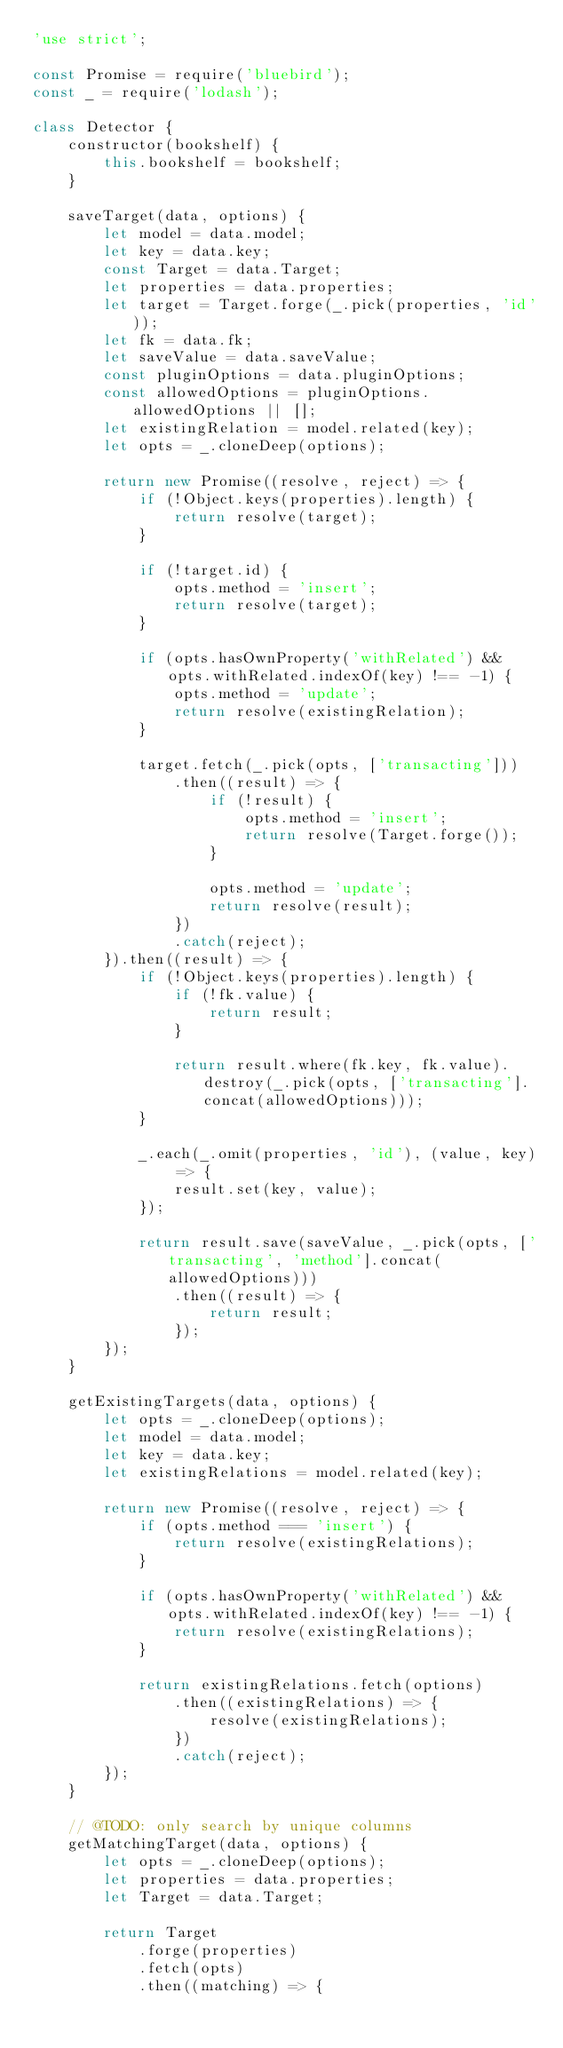Convert code to text. <code><loc_0><loc_0><loc_500><loc_500><_JavaScript_>'use strict';

const Promise = require('bluebird');
const _ = require('lodash');

class Detector {
    constructor(bookshelf) {
        this.bookshelf = bookshelf;
    }

    saveTarget(data, options) {
        let model = data.model;
        let key = data.key;
        const Target = data.Target;
        let properties = data.properties;
        let target = Target.forge(_.pick(properties, 'id'));
        let fk = data.fk;
        let saveValue = data.saveValue;
        const pluginOptions = data.pluginOptions;
        const allowedOptions = pluginOptions.allowedOptions || [];
        let existingRelation = model.related(key);
        let opts = _.cloneDeep(options);

        return new Promise((resolve, reject) => {
            if (!Object.keys(properties).length) {
                return resolve(target);
            }

            if (!target.id) {
                opts.method = 'insert';
                return resolve(target);
            }

            if (opts.hasOwnProperty('withRelated') && opts.withRelated.indexOf(key) !== -1) {
                opts.method = 'update';
                return resolve(existingRelation);
            }

            target.fetch(_.pick(opts, ['transacting']))
                .then((result) => {
                    if (!result) {
                        opts.method = 'insert';
                        return resolve(Target.forge());
                    }

                    opts.method = 'update';
                    return resolve(result);
                })
                .catch(reject);
        }).then((result) => {
            if (!Object.keys(properties).length) {
                if (!fk.value) {
                    return result;
                }

                return result.where(fk.key, fk.value).destroy(_.pick(opts, ['transacting'].concat(allowedOptions)));
            }

            _.each(_.omit(properties, 'id'), (value, key) => {
                result.set(key, value);
            });

            return result.save(saveValue, _.pick(opts, ['transacting', 'method'].concat(allowedOptions)))
                .then((result) => {
                    return result;
                });
        });
    }

    getExistingTargets(data, options) {
        let opts = _.cloneDeep(options);
        let model = data.model;
        let key = data.key;
        let existingRelations = model.related(key);

        return new Promise((resolve, reject) => {
            if (opts.method === 'insert') {
                return resolve(existingRelations);
            }

            if (opts.hasOwnProperty('withRelated') && opts.withRelated.indexOf(key) !== -1) {
                return resolve(existingRelations);
            }

            return existingRelations.fetch(options)
                .then((existingRelations) => {
                    resolve(existingRelations);
                })
                .catch(reject);
        });
    }

    // @TODO: only search by unique columns
    getMatchingTarget(data, options) {
        let opts = _.cloneDeep(options);
        let properties = data.properties;
        let Target = data.Target;

        return Target
            .forge(properties)
            .fetch(opts)
            .then((matching) => {</code> 